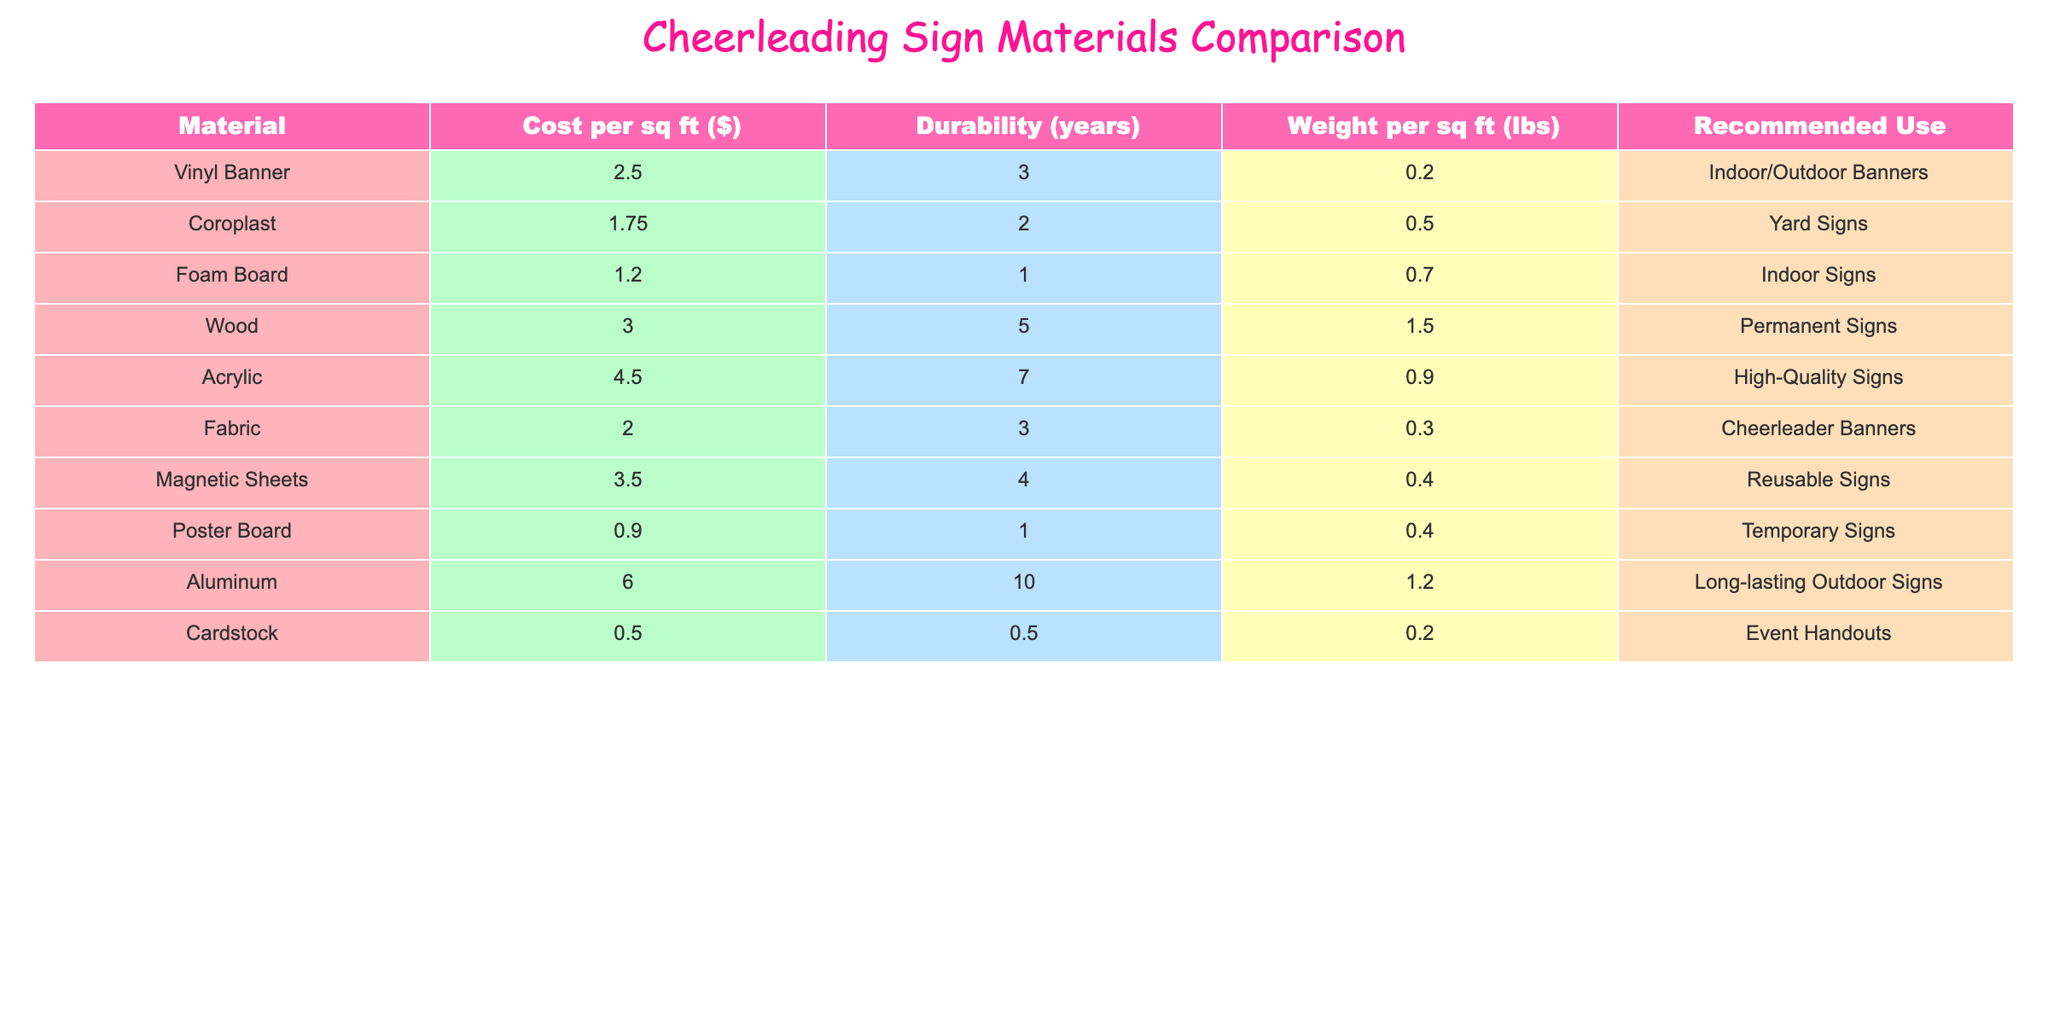What is the cost per square foot of a Vinyl Banner? The table lists the cost per square foot of each material. For Vinyl Banner, the entry shows that the cost is $2.50.
Answer: 2.50 Which material has the highest durability? The table includes a 'Durability' column showing the lifespan of each material in years. By comparing the values, Aluminum has the highest durability of 10 years.
Answer: Aluminum What is the total weight of 2 square feet of Foam Board? The weight per square foot of Foam Board is given as 0.7 lbs. Therefore, for 2 square feet, the total weight would be calculated as 0.7 lbs * 2 = 1.4 lbs.
Answer: 1.4 lbs Is Fabric more expensive than Coroplast? The cost per square foot for Fabric is $2.00, while for Coroplast it is $1.75. Since $2.00 is greater than $1.75, the statement is true.
Answer: Yes What is the average cost per square foot of the materials used for indoor signs? The materials listed for indoor signs are Foam Board and Vinyl Banner. Their costs are $1.20 and $2.50 respectively. The average cost is calculated as (1.20 + 2.50) / 2 = 1.85.
Answer: 1.85 What is the difference in cost per square foot between Wood and Acrylic? The cost per square foot of Wood is $3.00 and for Acrylic, it is $4.50. To find the difference, subtract the cost of Wood from that of Acrylic: $4.50 - $3.00 = $1.50.
Answer: 1.50 Which material is best for temporary signs based on cost and durability? The only material listed for temporary signs is Poster Board, which costs $0.90 per square foot and has a durability of 1 year. Comparing with others, it has the lowest durability among suitable options for temporary use due to its cost.
Answer: Poster Board List the materials that have a weight of less than 0.5 lbs per square foot. From the table, the materials with weight less than 0.5 lbs per square foot are Vinyl Banner (0.2 lbs), Fabric (0.3 lbs), and Cardstock (0.2 lbs).
Answer: Vinyl Banner, Fabric, Cardstock Which material has the longest lifespan and what is its recommended use? The table indicates that Aluminum has the longest lifespan of 10 years, and it is recommended for long-lasting outdoor signs.
Answer: Aluminum, Long-lasting Outdoor Signs 